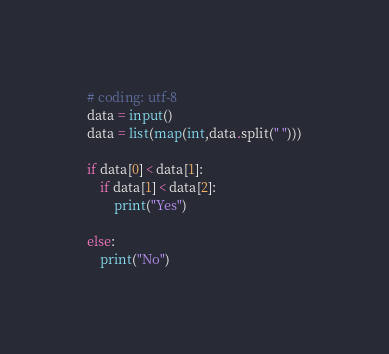Convert code to text. <code><loc_0><loc_0><loc_500><loc_500><_Python_># coding: utf-8
data = input()
data = list(map(int,data.split(" ")))

if data[0] < data[1]:
    if data[1] < data[2]:
        print("Yes")

else:
    print("No")</code> 